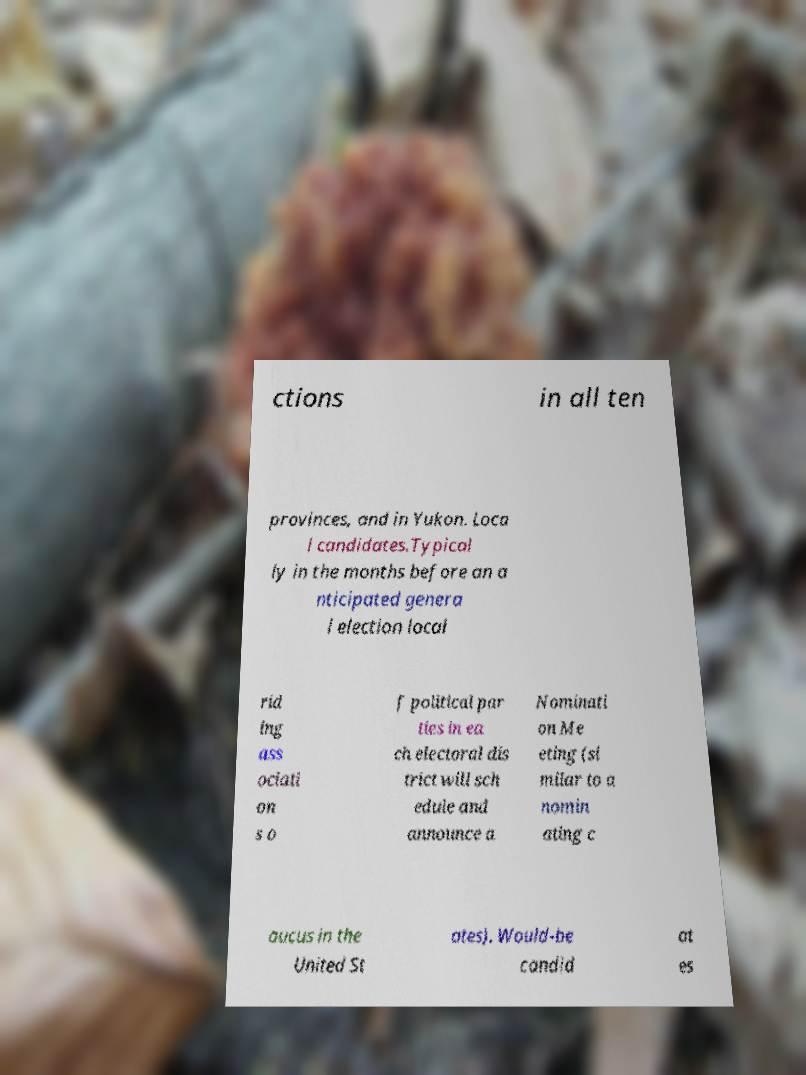For documentation purposes, I need the text within this image transcribed. Could you provide that? ctions in all ten provinces, and in Yukon. Loca l candidates.Typical ly in the months before an a nticipated genera l election local rid ing ass ociati on s o f political par ties in ea ch electoral dis trict will sch edule and announce a Nominati on Me eting (si milar to a nomin ating c aucus in the United St ates). Would-be candid at es 